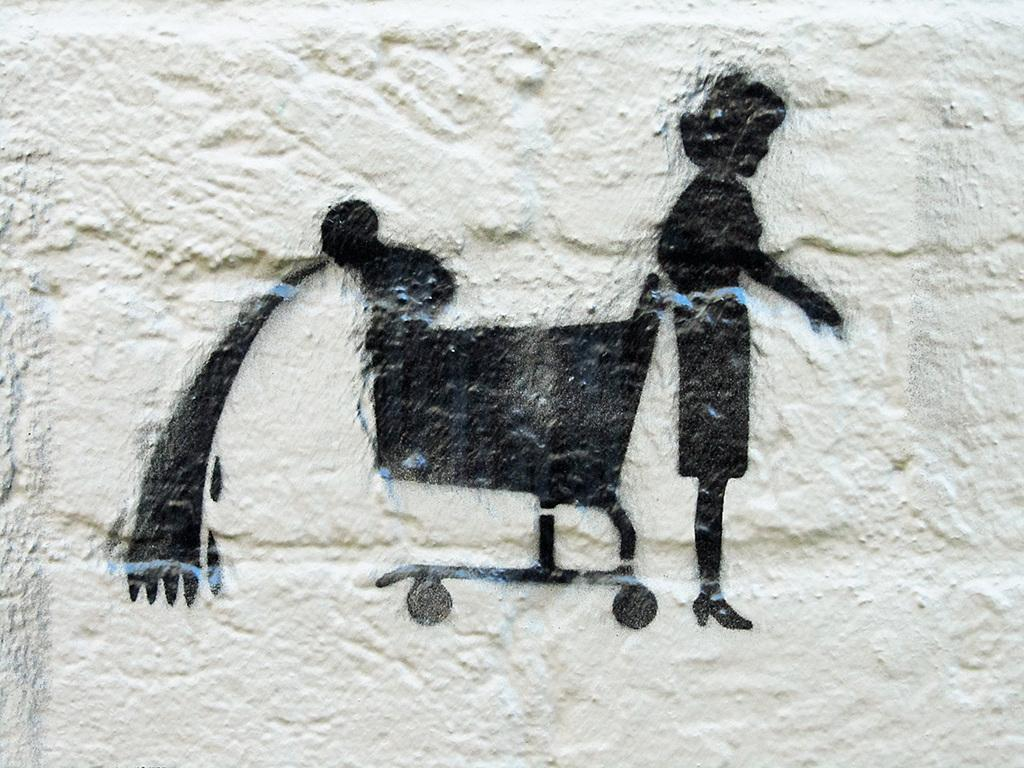What is the main subject of the painting in the image? The main subject of the painting in the image is a woman. What object is also present in the painting? There is a wheel cart depicted in the painting. Where is the painting located in the image? The painting is on a wall. What type of treatment is the woman receiving at the zoo in the image? There is no zoo or treatment present in the image; it features a painting of a woman with a wheel cart on a wall. What kind of beast can be seen interacting with the woman in the painting? There is no beast present in the painting; it only features a woman and a wheel cart. 